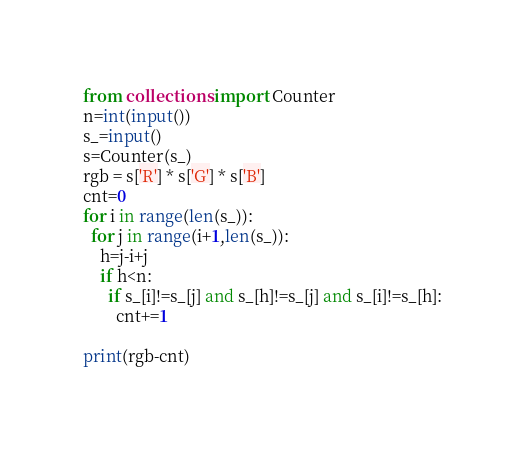Convert code to text. <code><loc_0><loc_0><loc_500><loc_500><_Python_>from collections import Counter
n=int(input())
s_=input()
s=Counter(s_)
rgb = s['R'] * s['G'] * s['B']
cnt=0
for i in range(len(s_)):
  for j in range(i+1,len(s_)):
    h=j-i+j
    if h<n:
      if s_[i]!=s_[j] and s_[h]!=s_[j] and s_[i]!=s_[h]:
        cnt+=1

print(rgb-cnt)
    </code> 